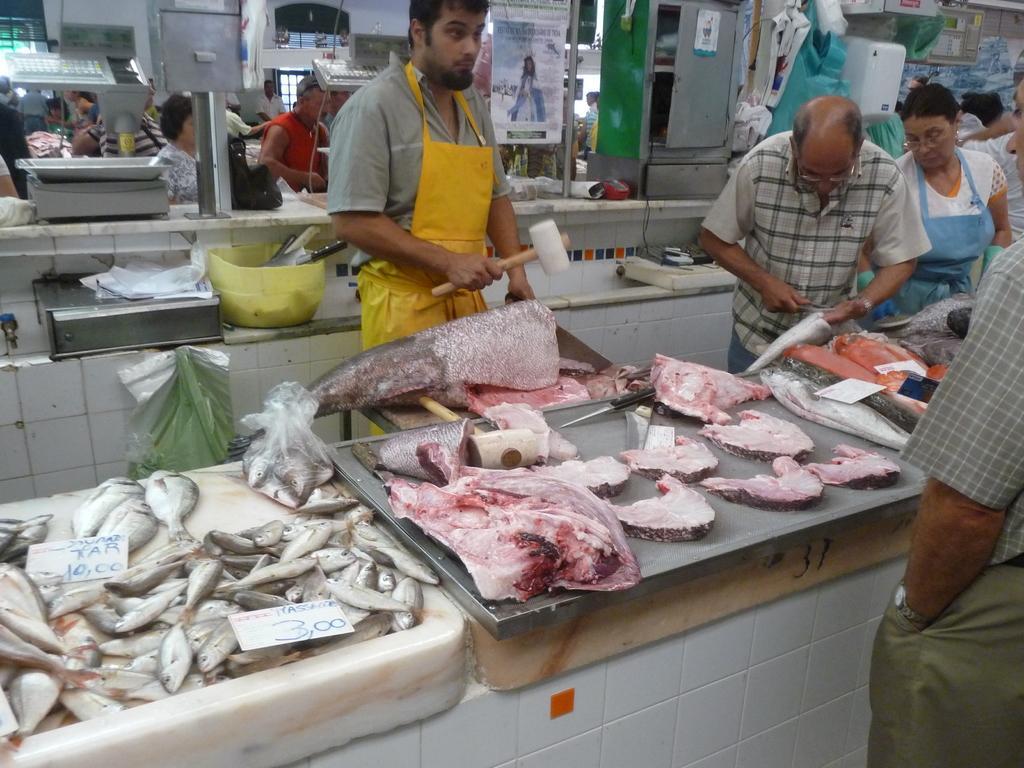Could you give a brief overview of what you see in this image? In this picture we can see a man standing in the kitchen and chopping the fish pieces. Behind we can see some and fish pieces in the silver tray. Behind we can see some people standing at the kitchen counter. 